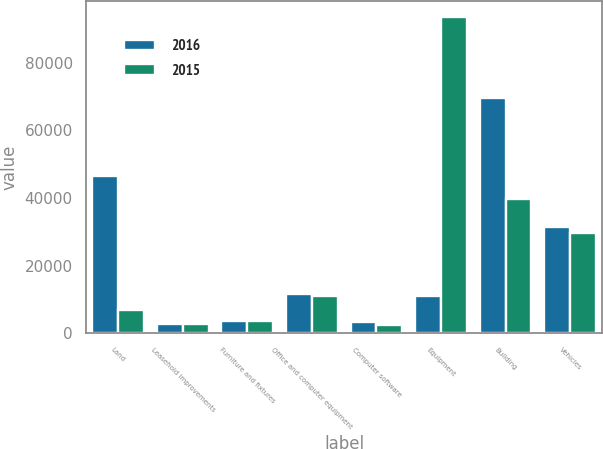Convert chart. <chart><loc_0><loc_0><loc_500><loc_500><stacked_bar_chart><ecel><fcel>Land<fcel>Leasehold improvements<fcel>Furniture and fixtures<fcel>Office and computer equipment<fcel>Computer software<fcel>Equipment<fcel>Building<fcel>Vehicles<nl><fcel>2016<fcel>46596<fcel>2687<fcel>3635<fcel>11701<fcel>3274<fcel>11080<fcel>69547<fcel>31582<nl><fcel>2015<fcel>6792<fcel>2804<fcel>3551<fcel>11080<fcel>2530<fcel>93465<fcel>39848<fcel>29804<nl></chart> 